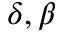Convert formula to latex. <formula><loc_0><loc_0><loc_500><loc_500>\delta , \beta</formula> 